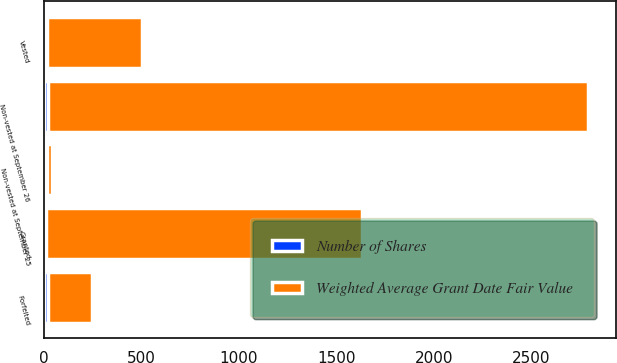<chart> <loc_0><loc_0><loc_500><loc_500><stacked_bar_chart><ecel><fcel>Non-vested at September 26<fcel>Granted<fcel>Vested<fcel>Forfeited<fcel>Non-vested at September 25<nl><fcel>Weighted Average Grant Date Fair Value<fcel>2770<fcel>1619<fcel>487<fcel>226<fcel>21.96<nl><fcel>Number of Shares<fcel>21.96<fcel>15.27<fcel>15.47<fcel>21.49<fcel>19.9<nl></chart> 